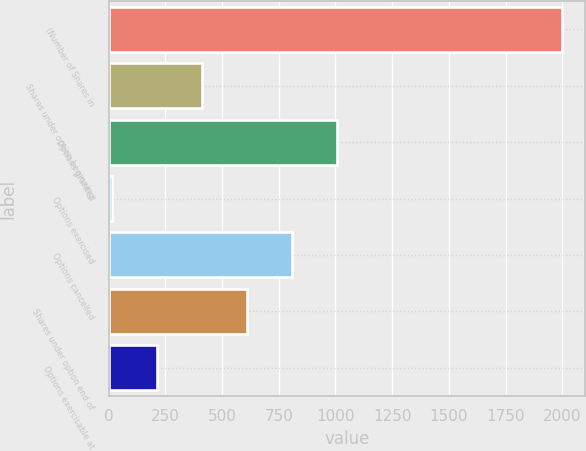Convert chart. <chart><loc_0><loc_0><loc_500><loc_500><bar_chart><fcel>(Number of Shares in<fcel>Shares under option beginning<fcel>Options granted<fcel>Options exercised<fcel>Options cancelled<fcel>Shares under option end of<fcel>Options exercisable at<nl><fcel>2001<fcel>412.2<fcel>1008<fcel>15<fcel>809.4<fcel>610.8<fcel>213.6<nl></chart> 